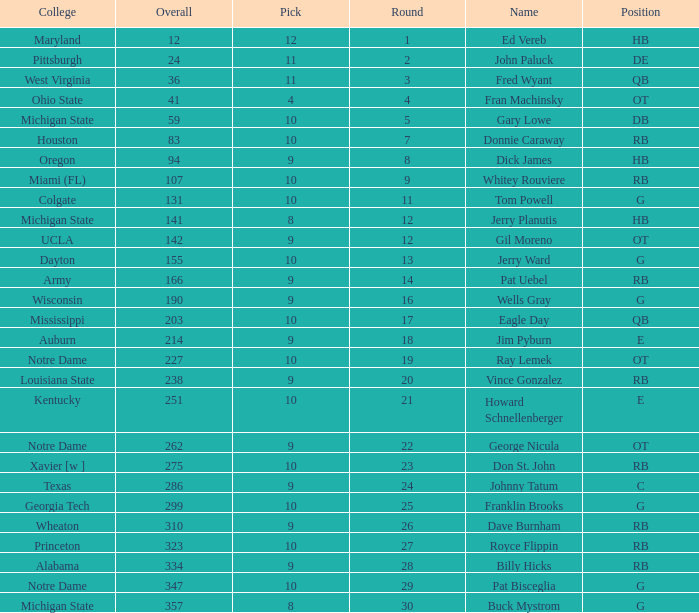Parse the full table. {'header': ['College', 'Overall', 'Pick', 'Round', 'Name', 'Position'], 'rows': [['Maryland', '12', '12', '1', 'Ed Vereb', 'HB'], ['Pittsburgh', '24', '11', '2', 'John Paluck', 'DE'], ['West Virginia', '36', '11', '3', 'Fred Wyant', 'QB'], ['Ohio State', '41', '4', '4', 'Fran Machinsky', 'OT'], ['Michigan State', '59', '10', '5', 'Gary Lowe', 'DB'], ['Houston', '83', '10', '7', 'Donnie Caraway', 'RB'], ['Oregon', '94', '9', '8', 'Dick James', 'HB'], ['Miami (FL)', '107', '10', '9', 'Whitey Rouviere', 'RB'], ['Colgate', '131', '10', '11', 'Tom Powell', 'G'], ['Michigan State', '141', '8', '12', 'Jerry Planutis', 'HB'], ['UCLA', '142', '9', '12', 'Gil Moreno', 'OT'], ['Dayton', '155', '10', '13', 'Jerry Ward', 'G'], ['Army', '166', '9', '14', 'Pat Uebel', 'RB'], ['Wisconsin', '190', '9', '16', 'Wells Gray', 'G'], ['Mississippi', '203', '10', '17', 'Eagle Day', 'QB'], ['Auburn', '214', '9', '18', 'Jim Pyburn', 'E'], ['Notre Dame', '227', '10', '19', 'Ray Lemek', 'OT'], ['Louisiana State', '238', '9', '20', 'Vince Gonzalez', 'RB'], ['Kentucky', '251', '10', '21', 'Howard Schnellenberger', 'E'], ['Notre Dame', '262', '9', '22', 'George Nicula', 'OT'], ['Xavier [w ]', '275', '10', '23', 'Don St. John', 'RB'], ['Texas', '286', '9', '24', 'Johnny Tatum', 'C'], ['Georgia Tech', '299', '10', '25', 'Franklin Brooks', 'G'], ['Wheaton', '310', '9', '26', 'Dave Burnham', 'RB'], ['Princeton', '323', '10', '27', 'Royce Flippin', 'RB'], ['Alabama', '334', '9', '28', 'Billy Hicks', 'RB'], ['Notre Dame', '347', '10', '29', 'Pat Bisceglia', 'G'], ['Michigan State', '357', '8', '30', 'Buck Mystrom', 'G']]} What is the overall pick number for a draft pick smaller than 9, named buck mystrom from Michigan State college? 357.0. 